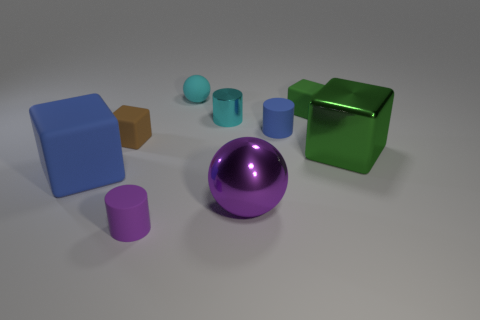Subtract all blue rubber cubes. How many cubes are left? 3 Subtract all purple blocks. Subtract all yellow balls. How many blocks are left? 4 Add 1 large matte blocks. How many objects exist? 10 Subtract all balls. How many objects are left? 7 Add 1 shiny objects. How many shiny objects are left? 4 Add 6 small metal things. How many small metal things exist? 7 Subtract 0 gray blocks. How many objects are left? 9 Subtract all tiny cyan metal objects. Subtract all brown objects. How many objects are left? 7 